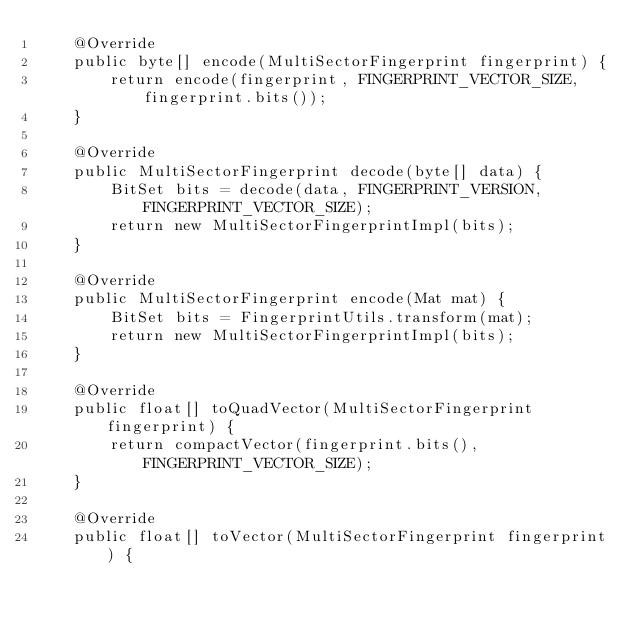<code> <loc_0><loc_0><loc_500><loc_500><_Java_>	@Override
	public byte[] encode(MultiSectorFingerprint fingerprint) {
		return encode(fingerprint, FINGERPRINT_VECTOR_SIZE, fingerprint.bits());
	}

	@Override
	public MultiSectorFingerprint decode(byte[] data) {
		BitSet bits = decode(data, FINGERPRINT_VERSION, FINGERPRINT_VECTOR_SIZE);
		return new MultiSectorFingerprintImpl(bits);
	}

	@Override
	public MultiSectorFingerprint encode(Mat mat) {
		BitSet bits = FingerprintUtils.transform(mat);
		return new MultiSectorFingerprintImpl(bits);
	}

	@Override
	public float[] toQuadVector(MultiSectorFingerprint fingerprint) {
		return compactVector(fingerprint.bits(), FINGERPRINT_VECTOR_SIZE);
	}

	@Override
	public float[] toVector(MultiSectorFingerprint fingerprint) {</code> 